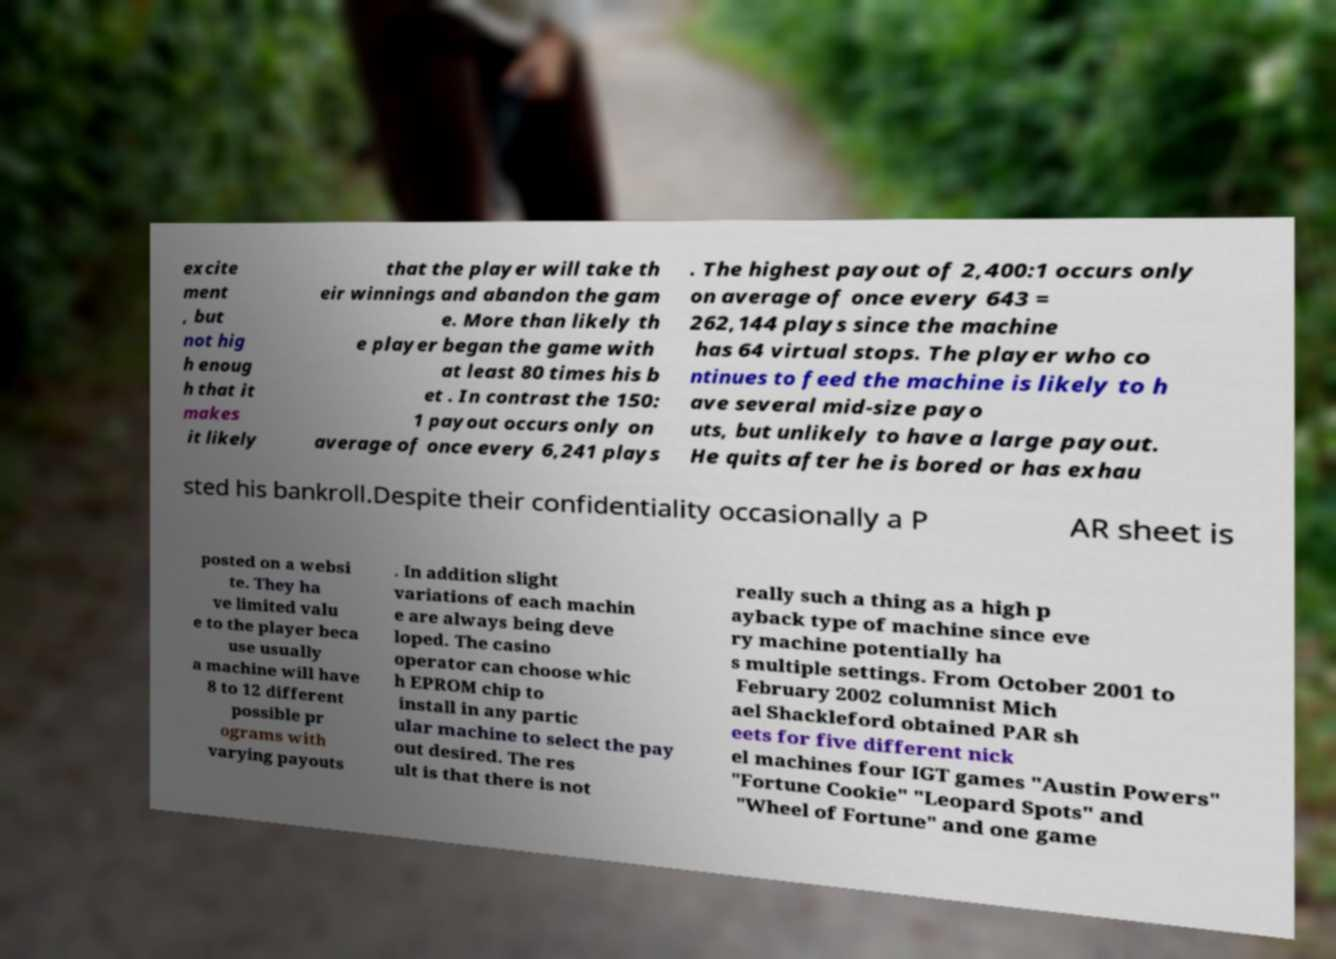There's text embedded in this image that I need extracted. Can you transcribe it verbatim? excite ment , but not hig h enoug h that it makes it likely that the player will take th eir winnings and abandon the gam e. More than likely th e player began the game with at least 80 times his b et . In contrast the 150: 1 payout occurs only on average of once every 6,241 plays . The highest payout of 2,400:1 occurs only on average of once every 643 = 262,144 plays since the machine has 64 virtual stops. The player who co ntinues to feed the machine is likely to h ave several mid-size payo uts, but unlikely to have a large payout. He quits after he is bored or has exhau sted his bankroll.Despite their confidentiality occasionally a P AR sheet is posted on a websi te. They ha ve limited valu e to the player beca use usually a machine will have 8 to 12 different possible pr ograms with varying payouts . In addition slight variations of each machin e are always being deve loped. The casino operator can choose whic h EPROM chip to install in any partic ular machine to select the pay out desired. The res ult is that there is not really such a thing as a high p ayback type of machine since eve ry machine potentially ha s multiple settings. From October 2001 to February 2002 columnist Mich ael Shackleford obtained PAR sh eets for five different nick el machines four IGT games "Austin Powers" "Fortune Cookie" "Leopard Spots" and "Wheel of Fortune" and one game 